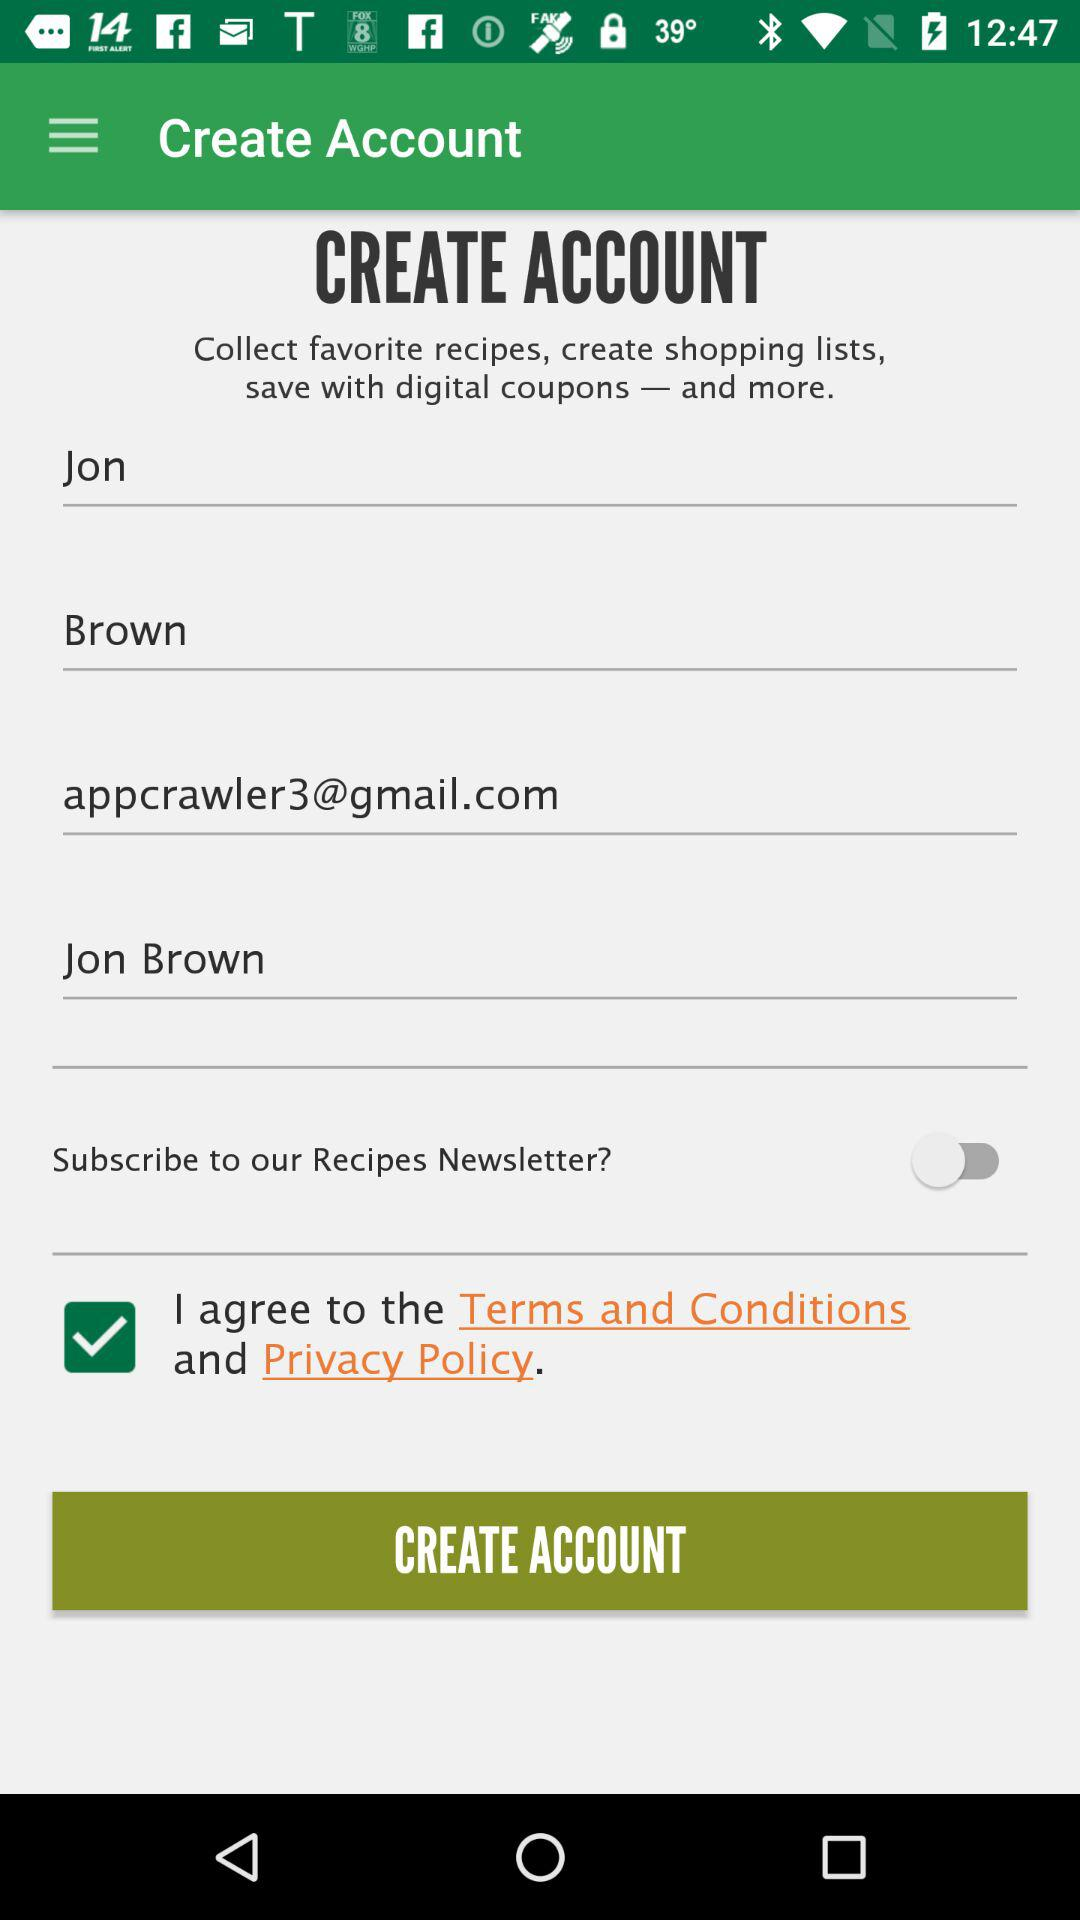What is the user name? The user name is Jon Brown. 